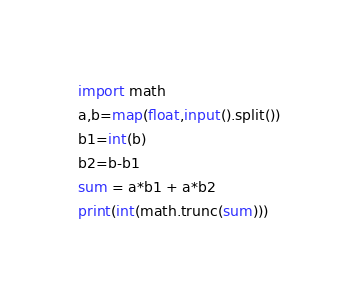<code> <loc_0><loc_0><loc_500><loc_500><_Python_>import math
a,b=map(float,input().split())
b1=int(b)
b2=b-b1
sum = a*b1 + a*b2
print(int(math.trunc(sum)))</code> 